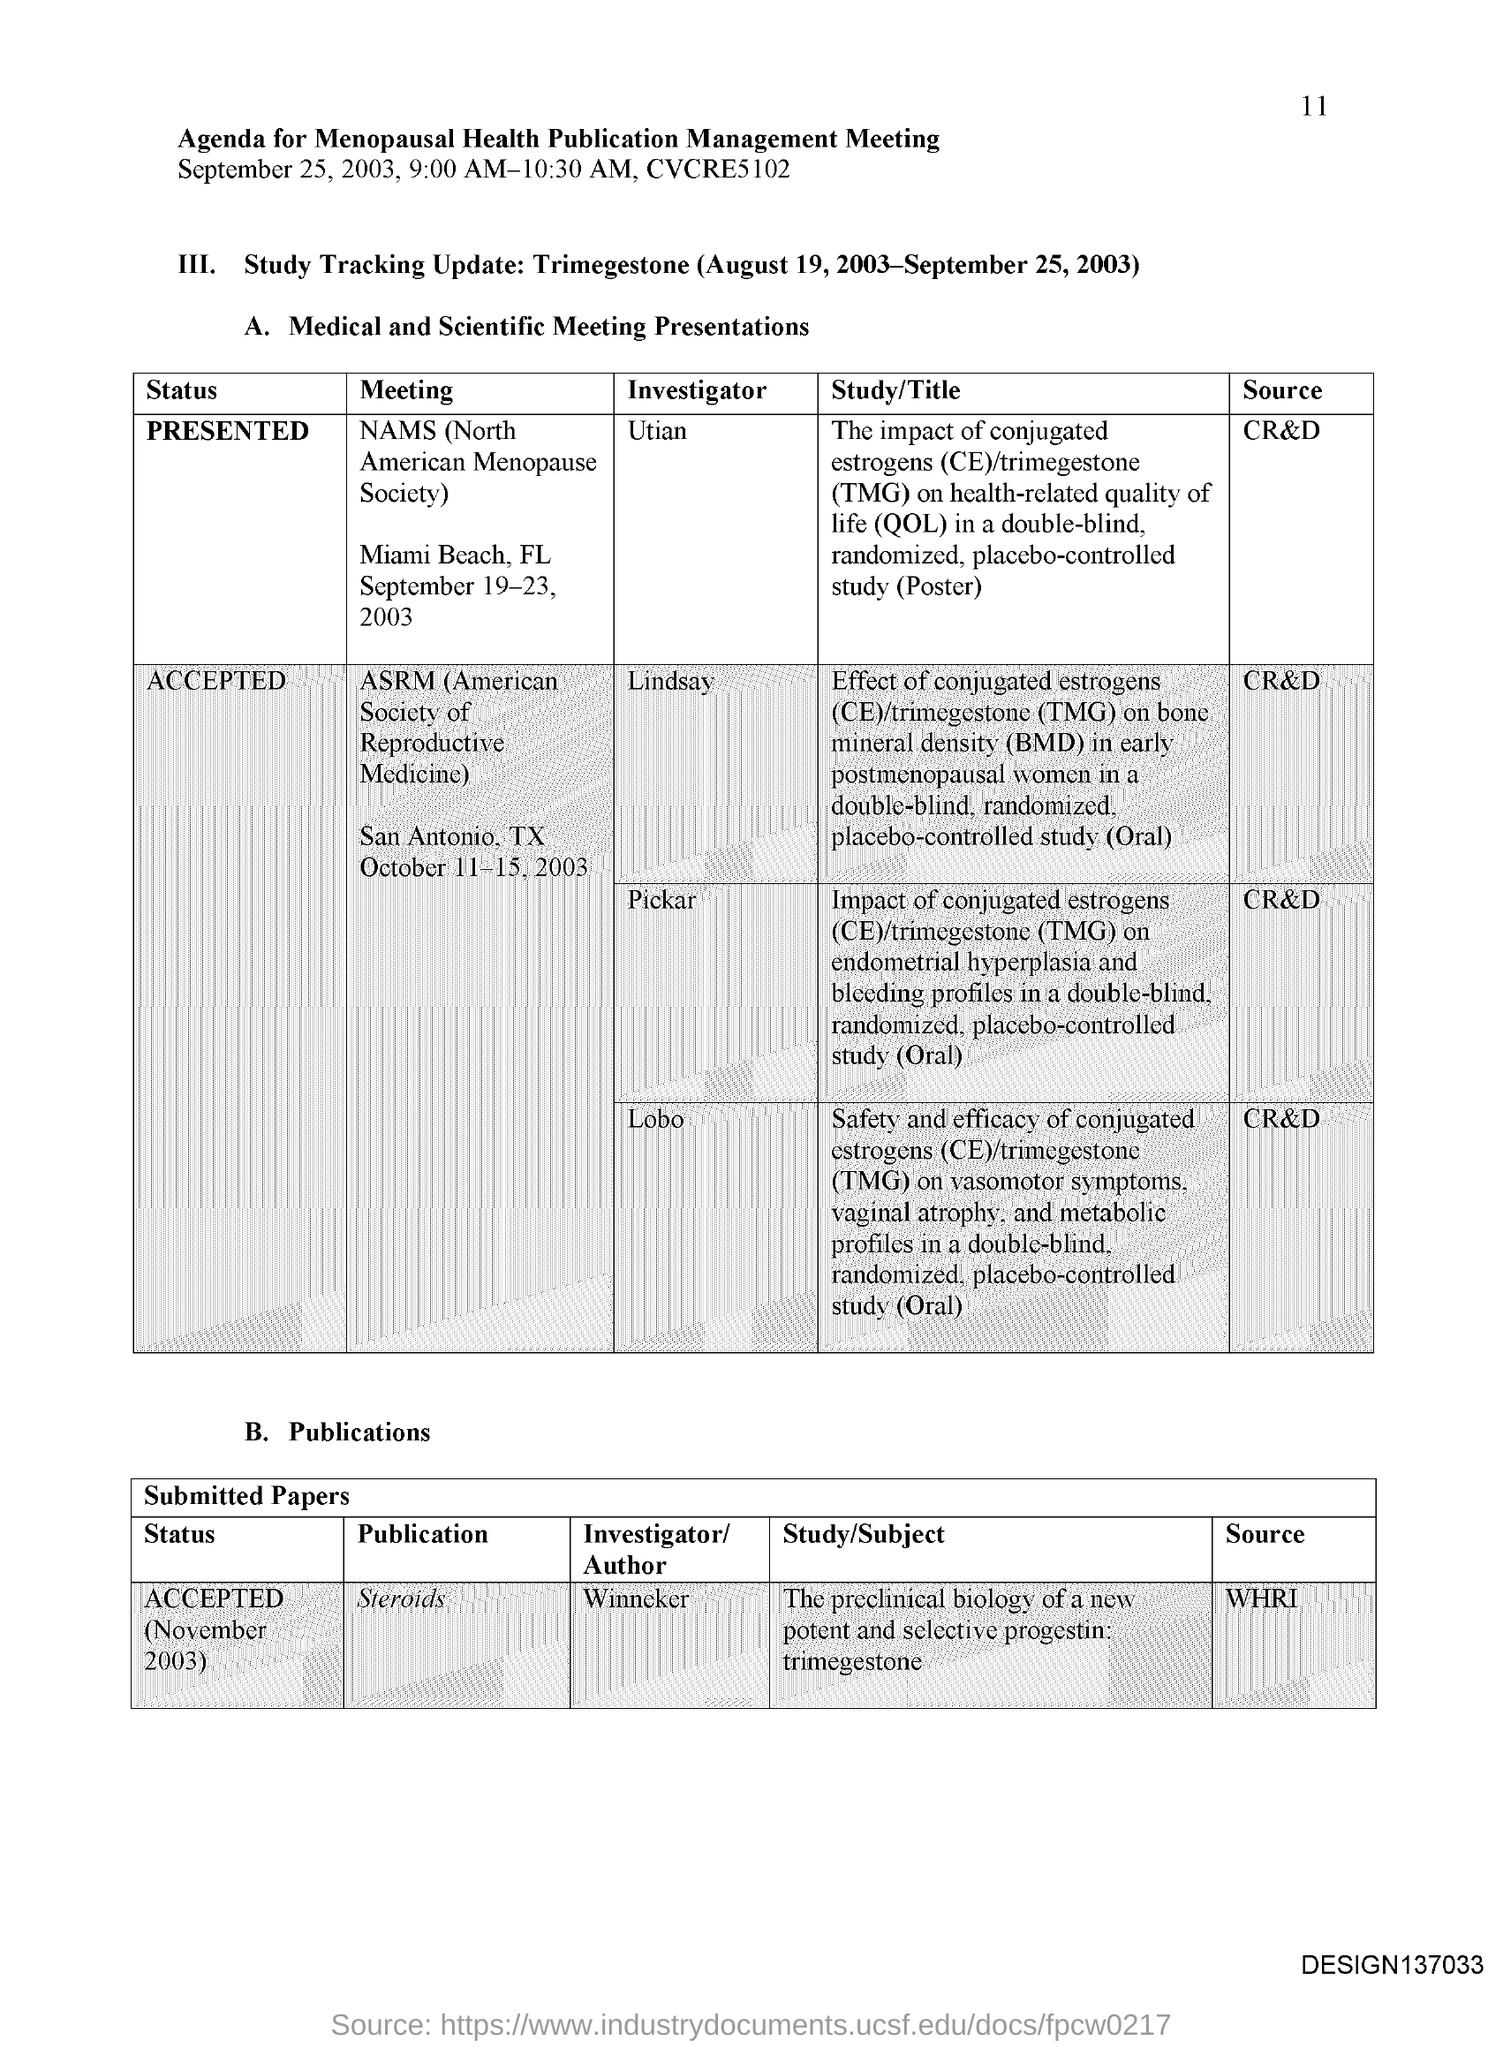When is the Menopausal Health Publication Management Meeting held?
Give a very brief answer. September 25, 2003, 9:00 AM-10:30 AM. What Time is the Menopausal Health Publication Management Meeting held?
Make the answer very short. 9:00 AM-10:30 AM. Who is the Investigator for Meeting "NAMS (North American Menopause Society)?
Give a very brief answer. Utian. Which is the Location for Meeting "NAMS (North American Menopause Society)?
Give a very brief answer. Miami beach, fl. When is the Meeting "NAMS (North American Menopause Society)?
Ensure brevity in your answer.  September 19-23, 2003. What does ASRM stand for?
Give a very brief answer. American Society of Reproductive Medicine. What does NAMS stand for?
Keep it short and to the point. North American Menopause Society. 